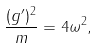<formula> <loc_0><loc_0><loc_500><loc_500>\frac { ( g ^ { \prime } ) ^ { 2 } } { m } = 4 \omega ^ { 2 } ,</formula> 